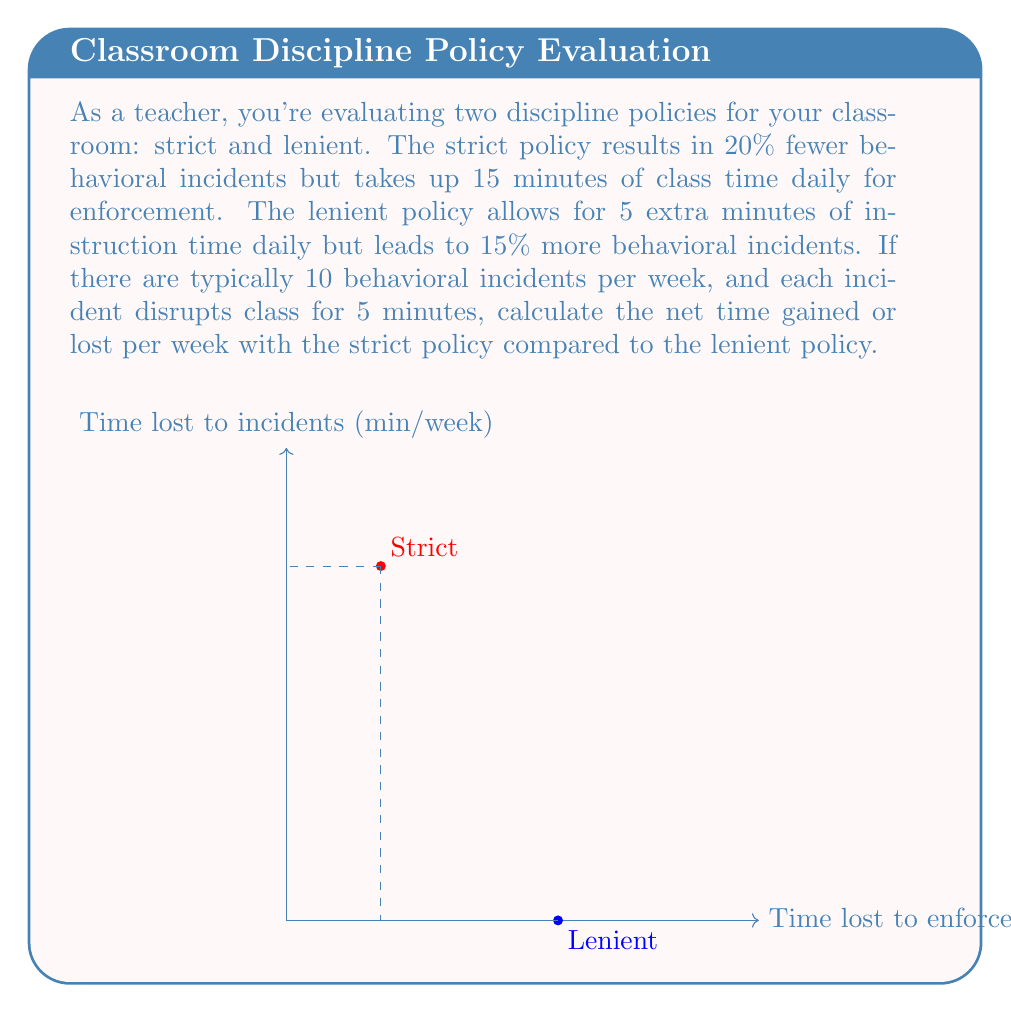Provide a solution to this math problem. Let's break this down step-by-step:

1) First, calculate the time spent on behavioral incidents per week for each policy:

   Lenient: 10 incidents/week * 1.15 (15% increase) * 5 minutes/incident = 57.5 minutes/week
   Strict: 10 incidents/week * 0.80 (20% decrease) * 5 minutes/incident = 40 minutes/week

2) Now, calculate the time spent on policy enforcement:

   Lenient: 0 minutes/day * 5 days = 0 minutes/week
   Strict: 15 minutes/day * 5 days = 75 minutes/week

3) Calculate the total time lost for each policy:

   Lenient: 57.5 + 0 = 57.5 minutes/week
   Strict: 40 + 75 = 115 minutes/week

4) Calculate the difference in instruction time:

   Lenient policy gains 5 extra minutes per day: 5 minutes/day * 5 days = 25 minutes/week

5) Calculate the net time difference:

   Time difference = Time lost (Strict - Lenient) - Extra instruction time with Lenient
   $$ \text{Net time} = (115 - 57.5) - 25 = 32.5 \text{ minutes} $$

Therefore, the strict policy results in a net loss of 32.5 minutes of class time per week compared to the lenient policy.
Answer: 32.5 minutes lost per week with strict policy 